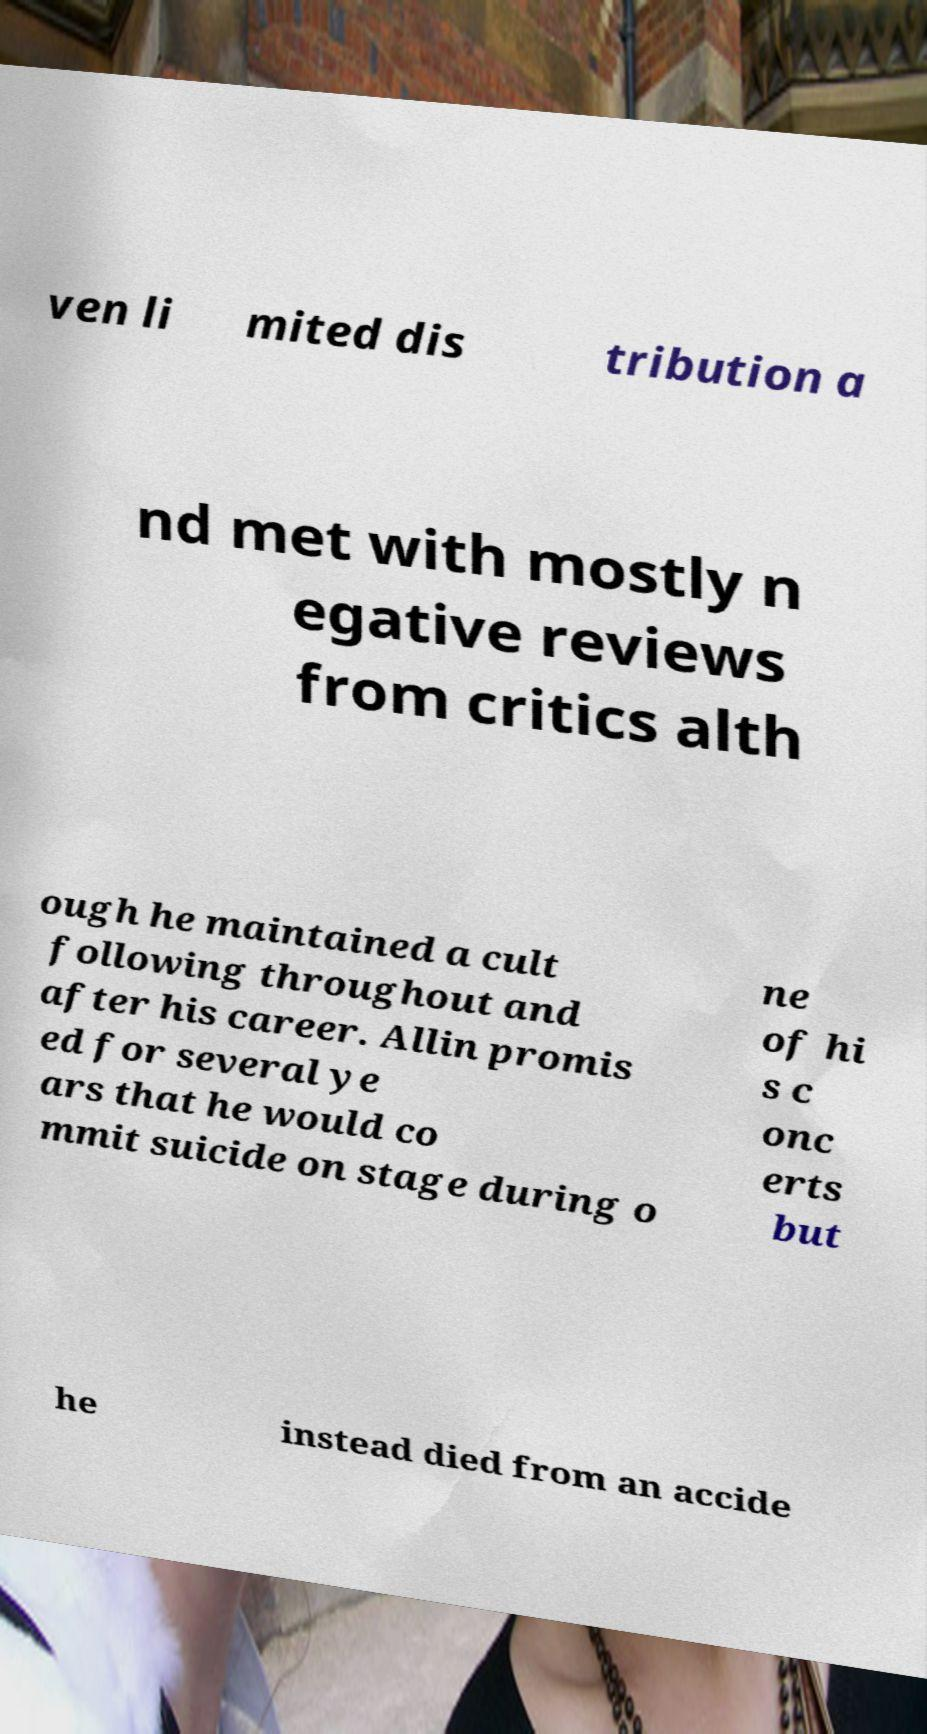For documentation purposes, I need the text within this image transcribed. Could you provide that? ven li mited dis tribution a nd met with mostly n egative reviews from critics alth ough he maintained a cult following throughout and after his career. Allin promis ed for several ye ars that he would co mmit suicide on stage during o ne of hi s c onc erts but he instead died from an accide 